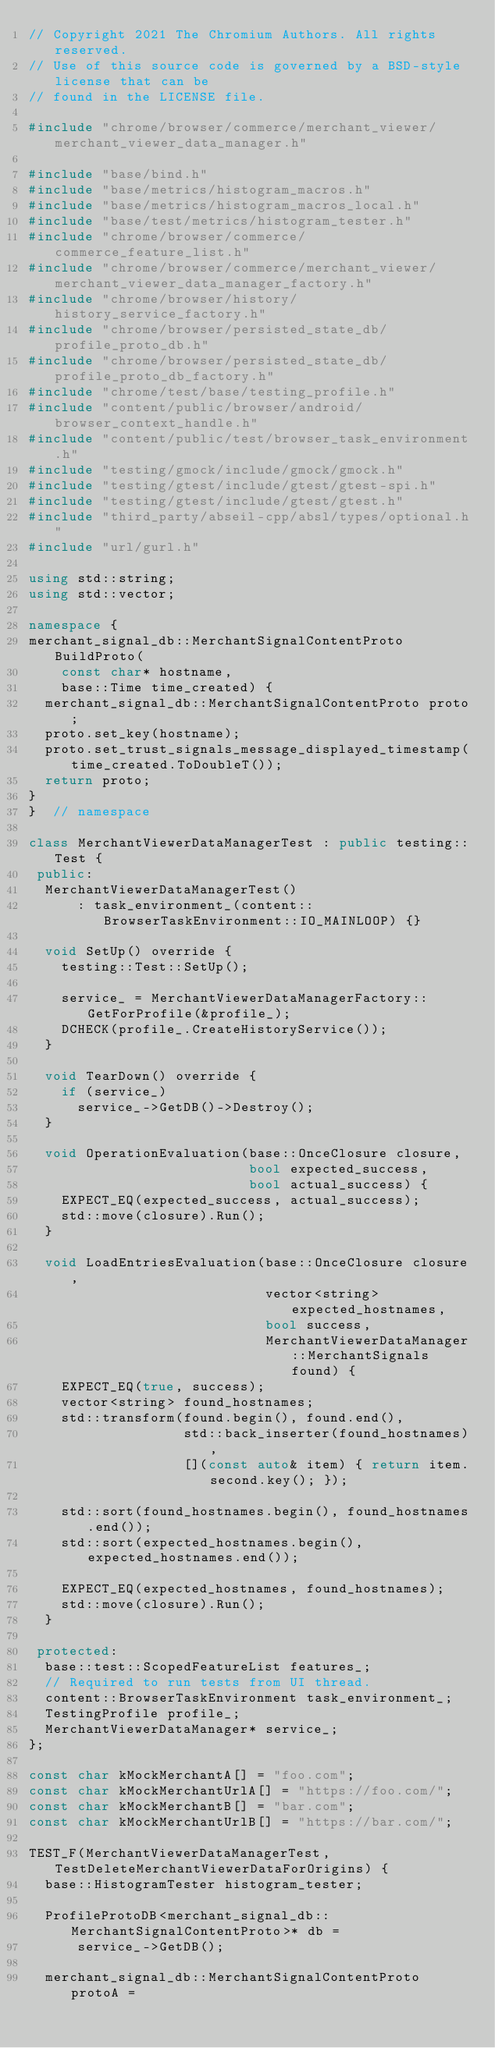Convert code to text. <code><loc_0><loc_0><loc_500><loc_500><_C++_>// Copyright 2021 The Chromium Authors. All rights reserved.
// Use of this source code is governed by a BSD-style license that can be
// found in the LICENSE file.

#include "chrome/browser/commerce/merchant_viewer/merchant_viewer_data_manager.h"

#include "base/bind.h"
#include "base/metrics/histogram_macros.h"
#include "base/metrics/histogram_macros_local.h"
#include "base/test/metrics/histogram_tester.h"
#include "chrome/browser/commerce/commerce_feature_list.h"
#include "chrome/browser/commerce/merchant_viewer/merchant_viewer_data_manager_factory.h"
#include "chrome/browser/history/history_service_factory.h"
#include "chrome/browser/persisted_state_db/profile_proto_db.h"
#include "chrome/browser/persisted_state_db/profile_proto_db_factory.h"
#include "chrome/test/base/testing_profile.h"
#include "content/public/browser/android/browser_context_handle.h"
#include "content/public/test/browser_task_environment.h"
#include "testing/gmock/include/gmock/gmock.h"
#include "testing/gtest/include/gtest/gtest-spi.h"
#include "testing/gtest/include/gtest/gtest.h"
#include "third_party/abseil-cpp/absl/types/optional.h"
#include "url/gurl.h"

using std::string;
using std::vector;

namespace {
merchant_signal_db::MerchantSignalContentProto BuildProto(
    const char* hostname,
    base::Time time_created) {
  merchant_signal_db::MerchantSignalContentProto proto;
  proto.set_key(hostname);
  proto.set_trust_signals_message_displayed_timestamp(time_created.ToDoubleT());
  return proto;
}
}  // namespace

class MerchantViewerDataManagerTest : public testing::Test {
 public:
  MerchantViewerDataManagerTest()
      : task_environment_(content::BrowserTaskEnvironment::IO_MAINLOOP) {}

  void SetUp() override {
    testing::Test::SetUp();

    service_ = MerchantViewerDataManagerFactory::GetForProfile(&profile_);
    DCHECK(profile_.CreateHistoryService());
  }

  void TearDown() override {
    if (service_)
      service_->GetDB()->Destroy();
  }

  void OperationEvaluation(base::OnceClosure closure,
                           bool expected_success,
                           bool actual_success) {
    EXPECT_EQ(expected_success, actual_success);
    std::move(closure).Run();
  }

  void LoadEntriesEvaluation(base::OnceClosure closure,
                             vector<string> expected_hostnames,
                             bool success,
                             MerchantViewerDataManager::MerchantSignals found) {
    EXPECT_EQ(true, success);
    vector<string> found_hostnames;
    std::transform(found.begin(), found.end(),
                   std::back_inserter(found_hostnames),
                   [](const auto& item) { return item.second.key(); });

    std::sort(found_hostnames.begin(), found_hostnames.end());
    std::sort(expected_hostnames.begin(), expected_hostnames.end());

    EXPECT_EQ(expected_hostnames, found_hostnames);
    std::move(closure).Run();
  }

 protected:
  base::test::ScopedFeatureList features_;
  // Required to run tests from UI thread.
  content::BrowserTaskEnvironment task_environment_;
  TestingProfile profile_;
  MerchantViewerDataManager* service_;
};

const char kMockMerchantA[] = "foo.com";
const char kMockMerchantUrlA[] = "https://foo.com/";
const char kMockMerchantB[] = "bar.com";
const char kMockMerchantUrlB[] = "https://bar.com/";

TEST_F(MerchantViewerDataManagerTest, TestDeleteMerchantViewerDataForOrigins) {
  base::HistogramTester histogram_tester;

  ProfileProtoDB<merchant_signal_db::MerchantSignalContentProto>* db =
      service_->GetDB();

  merchant_signal_db::MerchantSignalContentProto protoA =</code> 